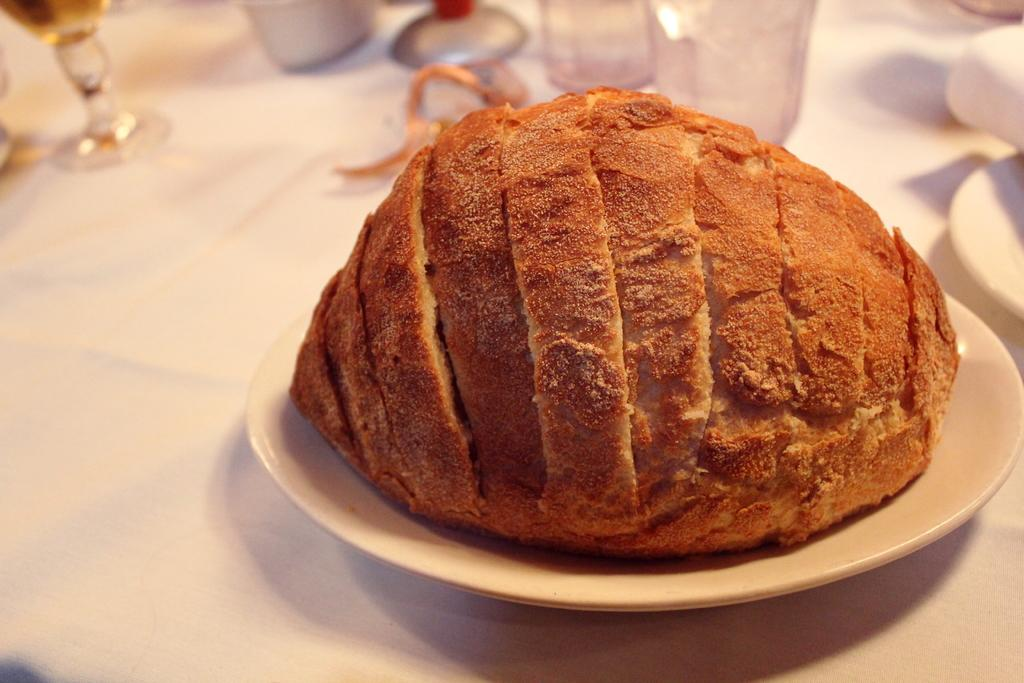What is the main food item visible on the plate in the image? Unfortunately, the specific food item cannot be determined from the given facts. What type of tableware is present on the table in the image? There are wine glasses on the table in the image. How many worms can be seen crawling on the food item in the image? There are no worms present in the image. 